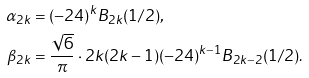<formula> <loc_0><loc_0><loc_500><loc_500>\alpha _ { 2 k } & = ( - 2 4 ) ^ { k } B _ { 2 k } ( 1 / 2 ) , \\ \beta _ { 2 k } & = \frac { \sqrt { 6 } } { \pi } \cdot 2 k ( 2 k - 1 ) ( - 2 4 ) ^ { k - 1 } B _ { 2 k - 2 } ( 1 / 2 ) .</formula> 